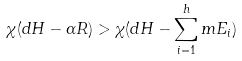<formula> <loc_0><loc_0><loc_500><loc_500>\chi ( d H - \alpha R ) > \chi ( d H - \sum _ { i = 1 } ^ { h } m E _ { i } )</formula> 